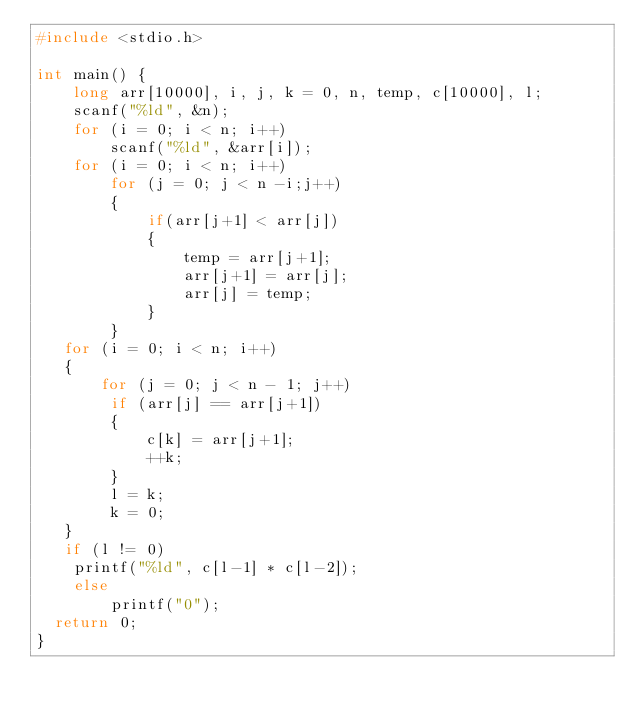<code> <loc_0><loc_0><loc_500><loc_500><_C_>#include <stdio.h>

int main() {
    long arr[10000], i, j, k = 0, n, temp, c[10000], l;
    scanf("%ld", &n);
    for (i = 0; i < n; i++)
        scanf("%ld", &arr[i]);
    for (i = 0; i < n; i++)
        for (j = 0; j < n -i;j++)
        {
            if(arr[j+1] < arr[j])
            {
                temp = arr[j+1];
                arr[j+1] = arr[j];
                arr[j] = temp;
            }
        }
   for (i = 0; i < n; i++)
   { 
       for (j = 0; j < n - 1; j++)
        if (arr[j] == arr[j+1])
        {
            c[k] = arr[j+1];
            ++k;
        }
        l = k;
        k = 0;
   }
   if (l != 0)
    printf("%ld", c[l-1] * c[l-2]);
    else
        printf("0");
	return 0;
}</code> 